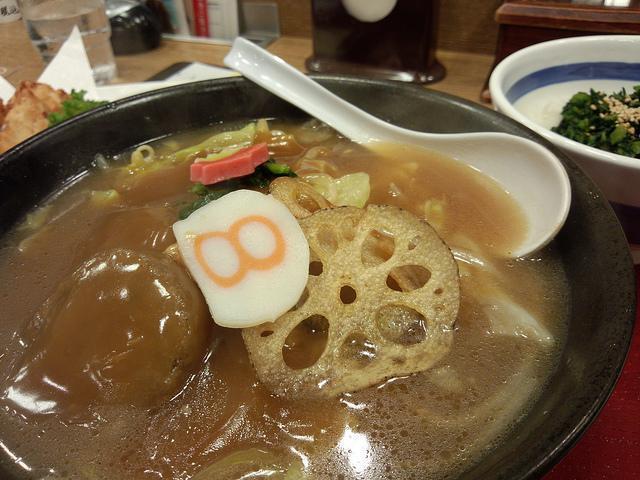How many bowls are there?
Give a very brief answer. 2. 